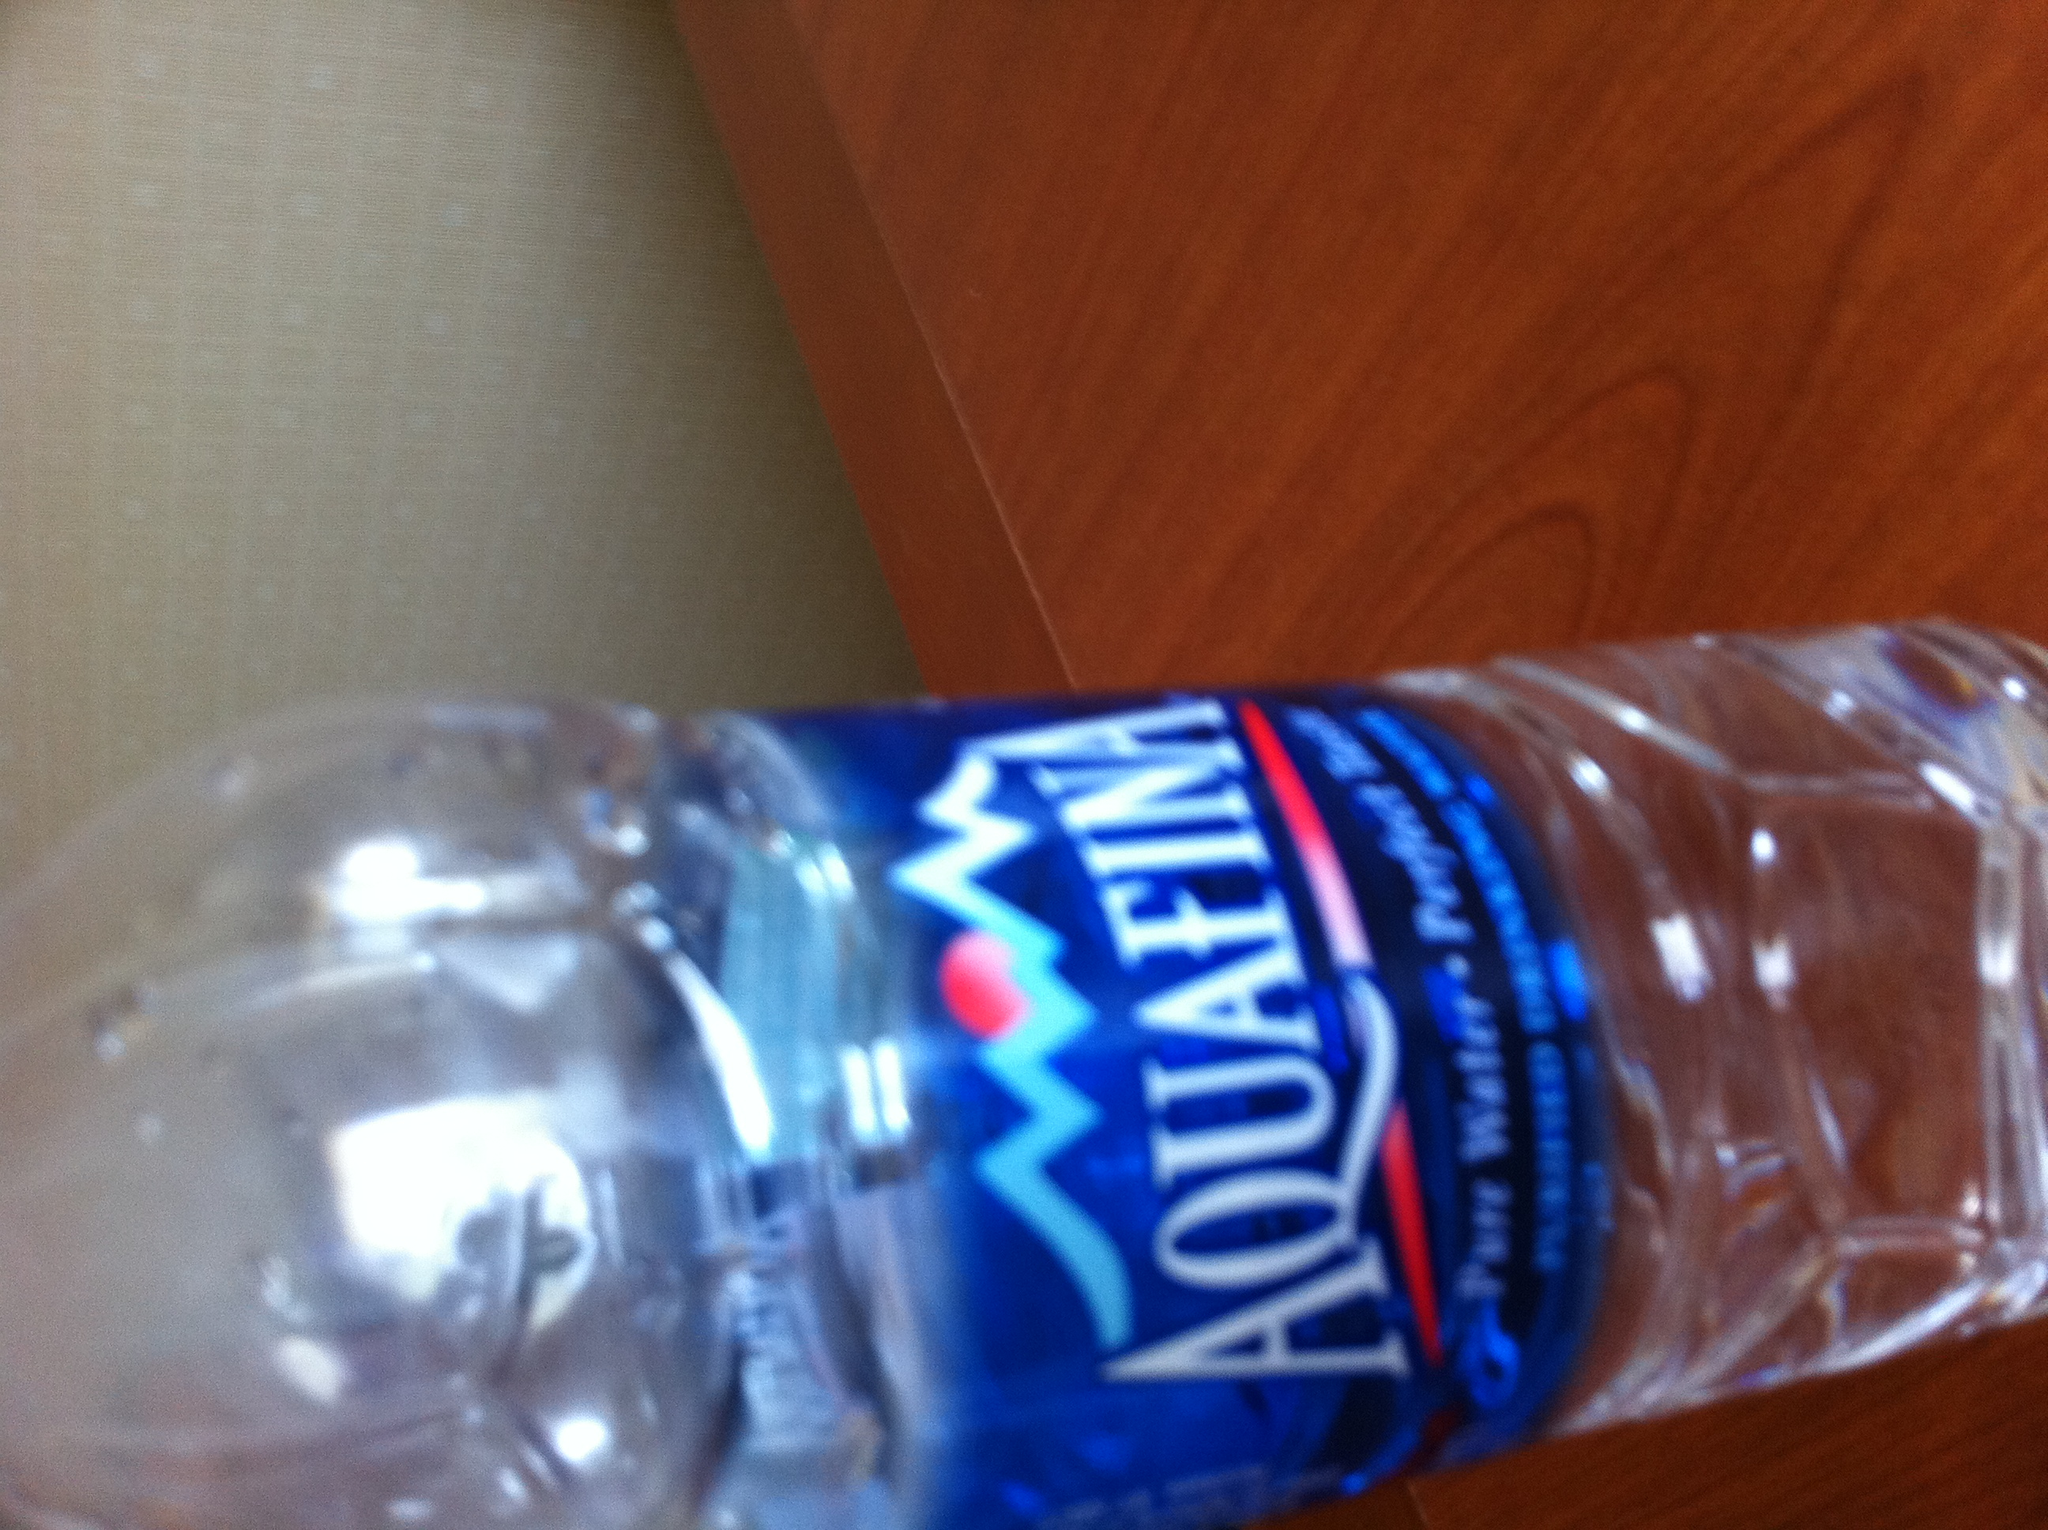What kind of water is this? This is Aquafina bottled water, which is a brand of purified water that goes through a rigorous filtration process including reverse osmosis, ultraviolet, and ozone sterilization to ensure its purity. 